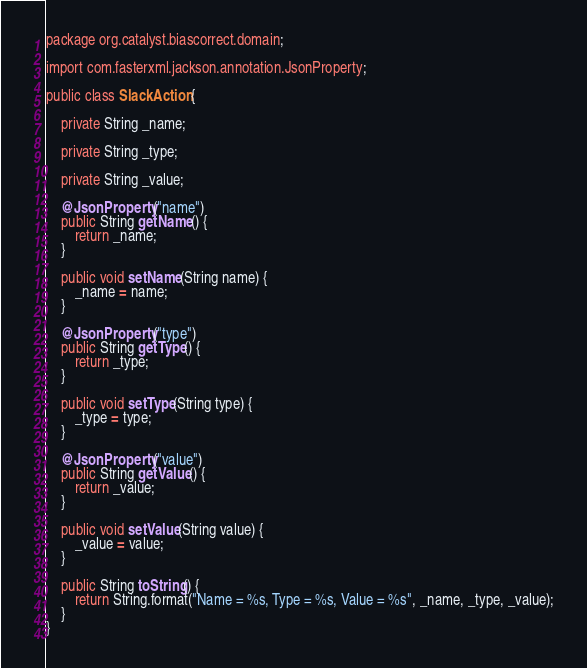<code> <loc_0><loc_0><loc_500><loc_500><_Java_>package org.catalyst.biascorrect.domain;

import com.fasterxml.jackson.annotation.JsonProperty;

public class SlackAction {

    private String _name;

    private String _type;

    private String _value;

    @JsonProperty("name")
    public String getName() {
        return _name;
    }

    public void setName(String name) {
        _name = name;
    }

    @JsonProperty("type")
    public String getType() {
        return _type;
    }

    public void setType(String type) {
        _type = type;
    }

    @JsonProperty("value")
    public String getValue() {
        return _value;
    }

    public void setValue(String value) {
        _value = value;
    }

    public String toString() {
        return String.format("Name = %s, Type = %s, Value = %s", _name, _type, _value);
    }
}
</code> 